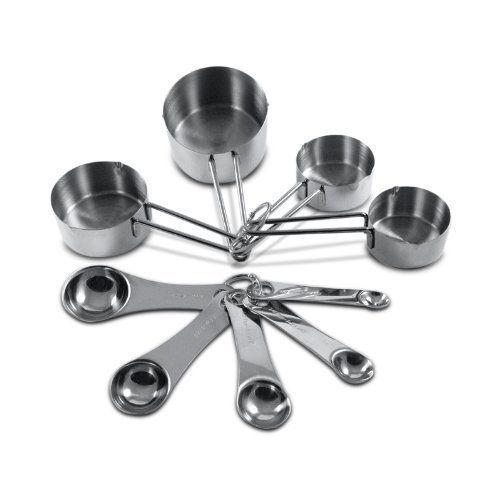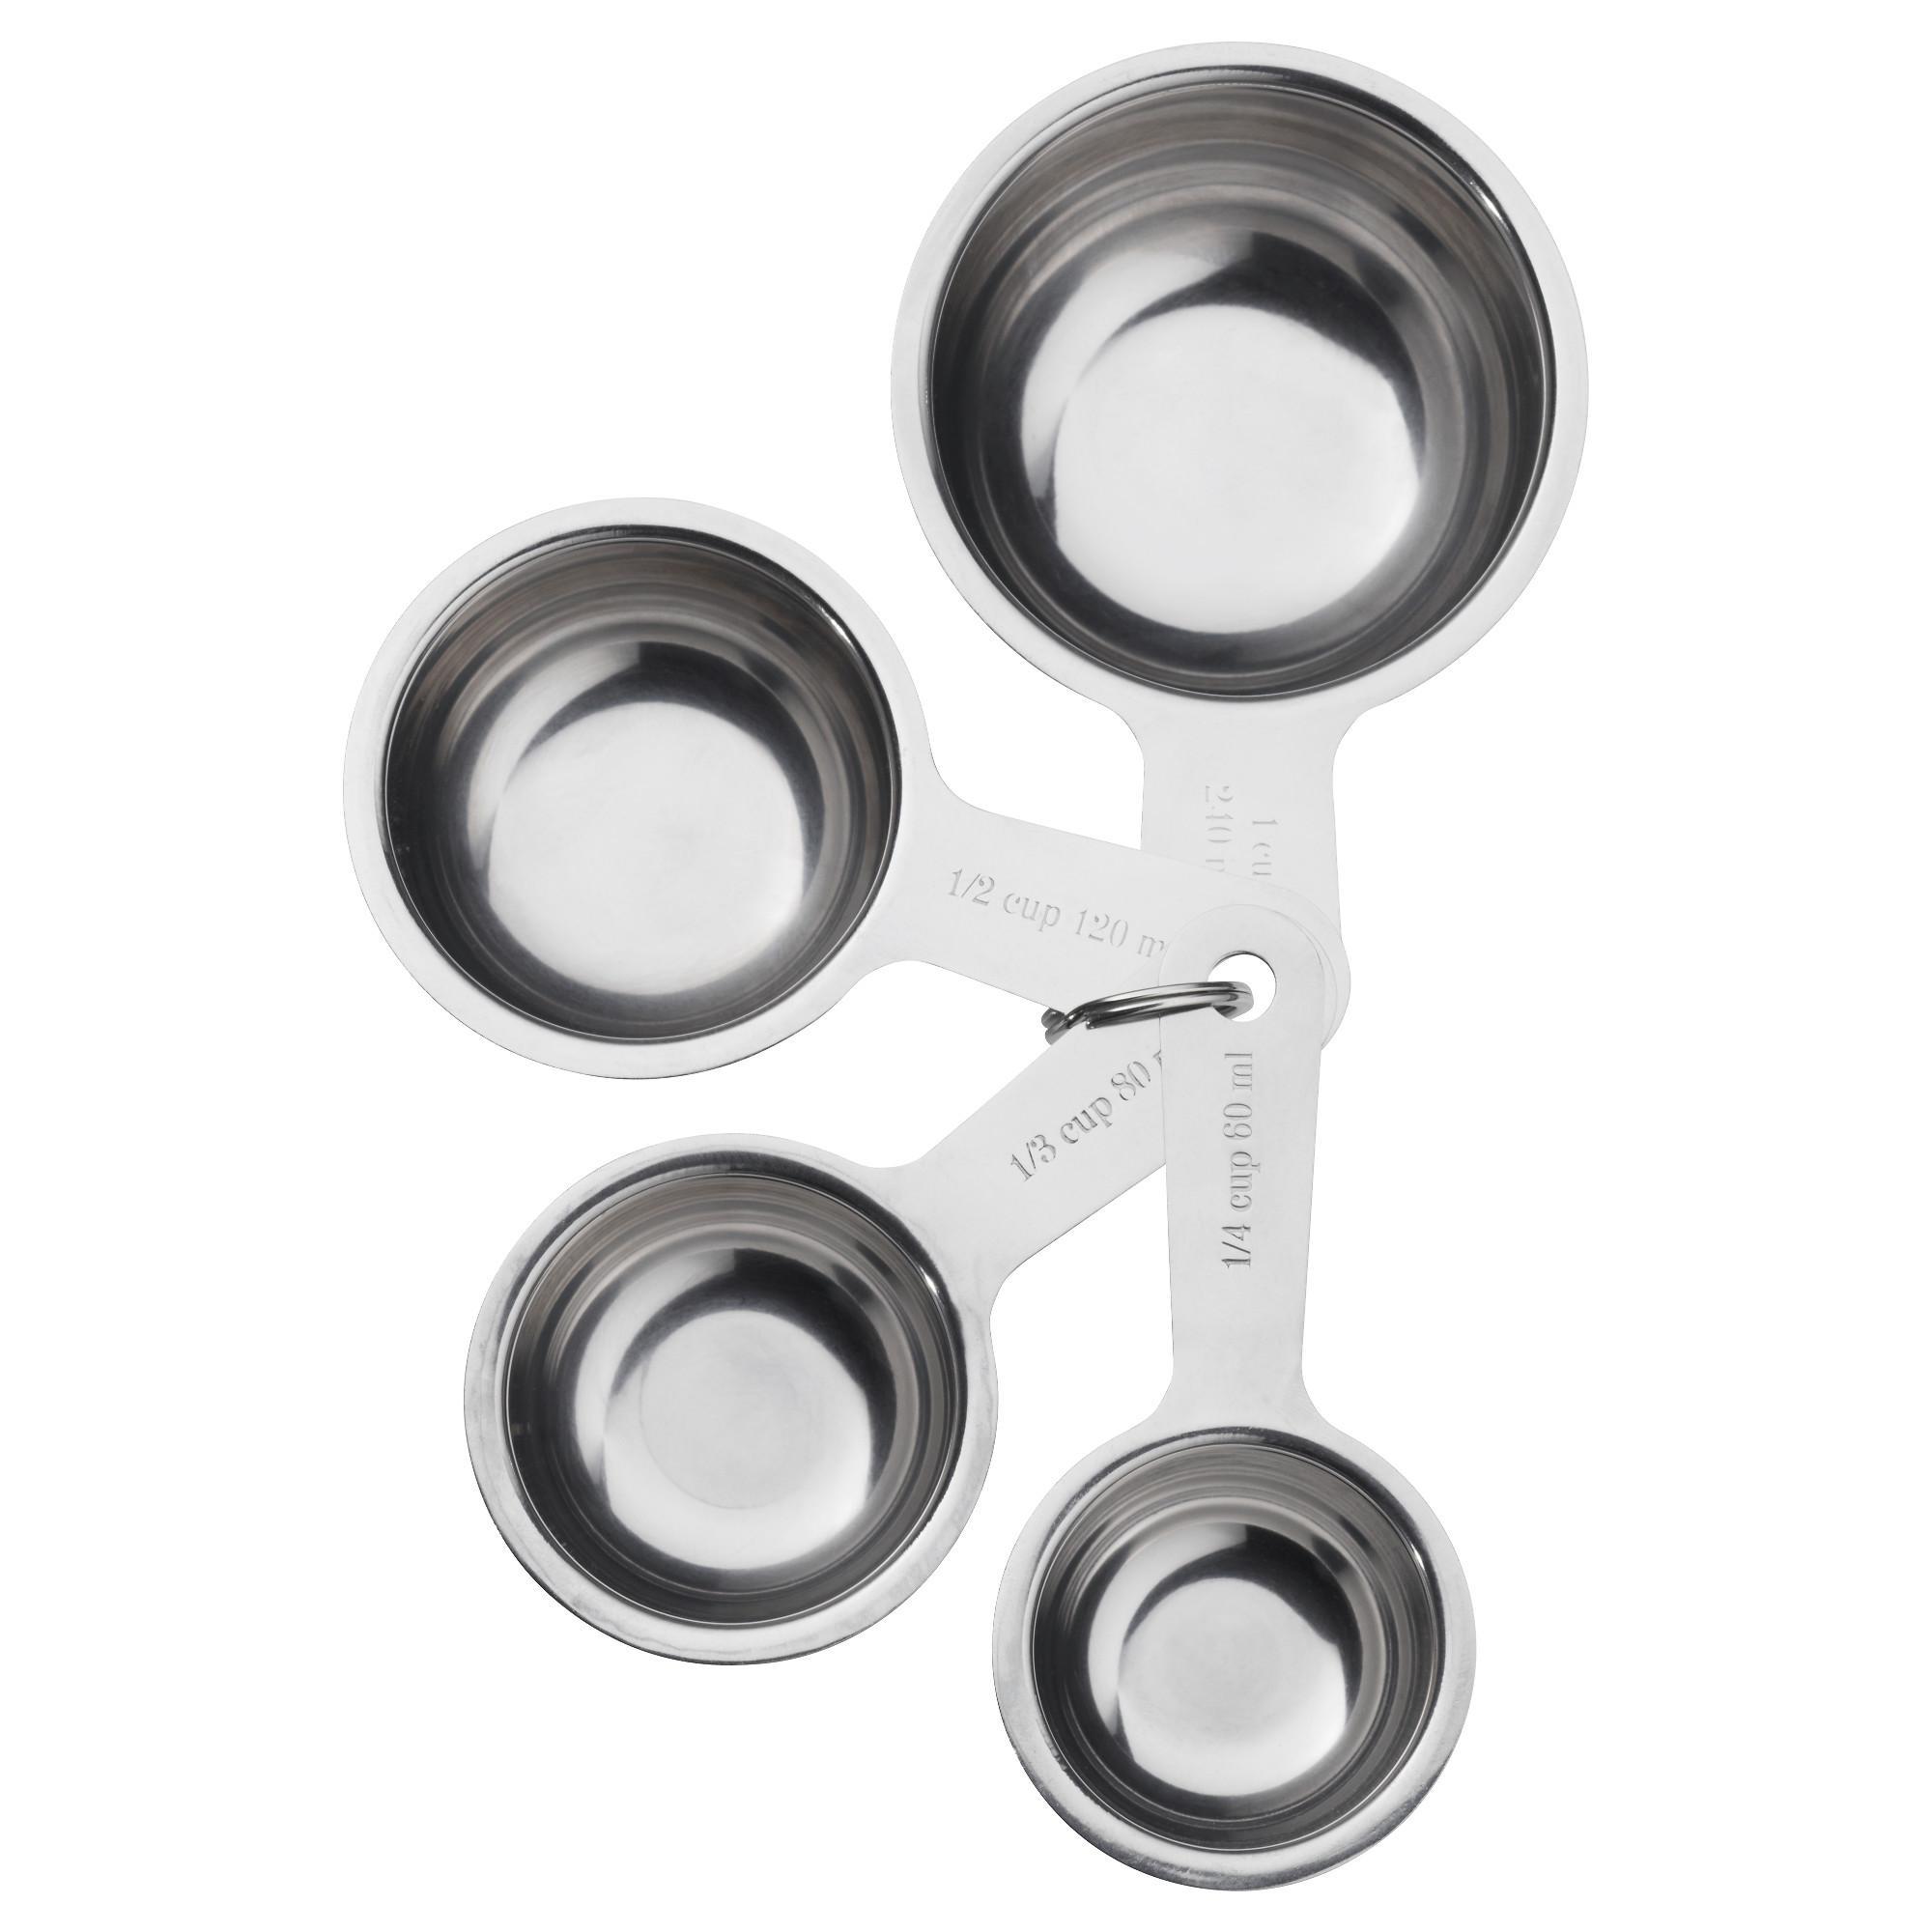The first image is the image on the left, the second image is the image on the right. Evaluate the accuracy of this statement regarding the images: "An image features only a joined group of exactly four measuring cups.". Is it true? Answer yes or no. Yes. 